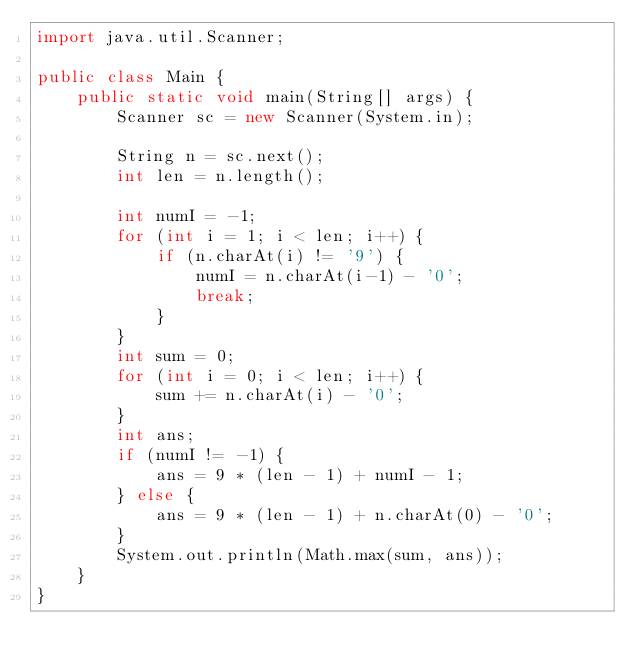<code> <loc_0><loc_0><loc_500><loc_500><_Java_>import java.util.Scanner;

public class Main {
    public static void main(String[] args) {
        Scanner sc = new Scanner(System.in);

        String n = sc.next();
        int len = n.length();
        
        int numI = -1;
        for (int i = 1; i < len; i++) {
            if (n.charAt(i) != '9') {
                numI = n.charAt(i-1) - '0';
                break;
            }
        }
        int sum = 0;
        for (int i = 0; i < len; i++) {
            sum += n.charAt(i) - '0';
        }
        int ans;
        if (numI != -1) {
            ans = 9 * (len - 1) + numI - 1;
        } else {
            ans = 9 * (len - 1) + n.charAt(0) - '0';
        }
        System.out.println(Math.max(sum, ans));
    }
}</code> 